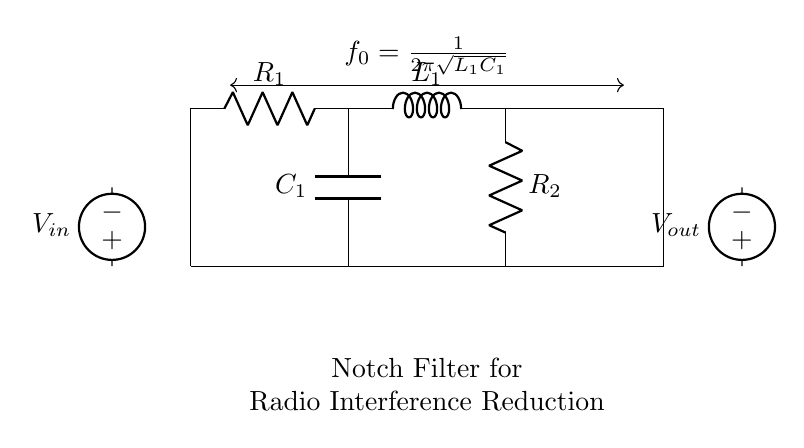What type of filter is depicted in the circuit diagram? The circuit diagram displays a notch filter, which is characterized by its ability to attenuate a narrow band of frequencies while allowing others to pass. This is evident by the labeled components and the lack of feedback loops that are typical in notch filters.
Answer: notch filter What is the function of the voltage source labeled V_in? The voltage source labeled V_in serves as the input signal for the filter circuit. It provides the alternating current (AC) that contains the radio frequencies subject to interference, which the filter is designed to modify.
Answer: input signal What does the label \( f_0 \) represent in the diagram? The label \( f_0 \) represents the resonant frequency of the notch filter, defined mathematically as \( \frac{1}{2\pi\sqrt{L_1C_1}} \). This equation shows how \( f_0 \) is influenced by the values of the inductor \( L_1 \) and capacitor \( C_1 \) in the circuit.
Answer: resonant frequency What are the roles of the components R_1 and R_2 in the circuit? R_1 and R_2 serve as resistors within the notch filter, affecting the impedance and frequency response of the circuit. R_1 is part of the series configuration with L_1 and eliminates a portion of the input current, while R_2 is used in the lower part of the circuit to set the output impedance. Both resistors help determine the quality and bandwidth of the filtering action.
Answer: resistors for impedance What is the expected effect on radio signals at the frequency \( f_0 \)? At the frequency \( f_0 \), the notch filter is expected to significantly attenuate or reduce the amplitude of the radio signals. This characteristic implies that signals at this specific frequency will be weakened, helping to filter out interference, while signals at other frequencies remain unaffected.
Answer: attenuation of interference How does changing the value of \( C_1 \) affect the filter's behavior? Changing the value of \( C_1 \) alters the resonant frequency \( f_0 \) according to the formula \( f_0 = \frac{1}{2\pi\sqrt{L_1C_1}} \). An increase in \( C_1 \) will lower \( f_0 \), shifting the notch to a lower frequency, whereas a decrease will raise \( f_0 \), moving the notch to a higher frequency. This control over the resonant frequency enables tuning the circuit to effectively mitigate specific interference frequencies.
Answer: alters resonant frequency 